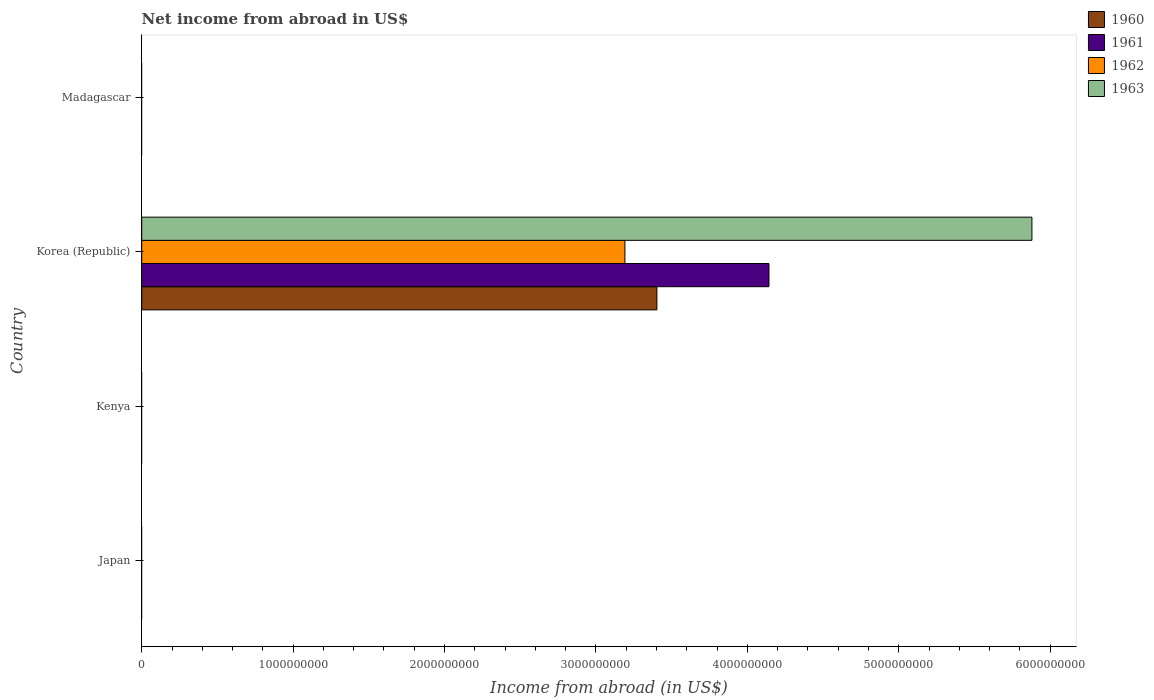How many different coloured bars are there?
Your answer should be very brief. 4. Are the number of bars per tick equal to the number of legend labels?
Provide a succinct answer. No. Are the number of bars on each tick of the Y-axis equal?
Your response must be concise. No. What is the label of the 3rd group of bars from the top?
Keep it short and to the point. Kenya. Across all countries, what is the maximum net income from abroad in 1963?
Offer a terse response. 5.88e+09. Across all countries, what is the minimum net income from abroad in 1961?
Keep it short and to the point. 0. What is the total net income from abroad in 1963 in the graph?
Your answer should be compact. 5.88e+09. What is the difference between the net income from abroad in 1961 in Kenya and the net income from abroad in 1962 in Madagascar?
Offer a terse response. 0. What is the average net income from abroad in 1963 per country?
Provide a short and direct response. 1.47e+09. What is the difference between the net income from abroad in 1960 and net income from abroad in 1963 in Korea (Republic)?
Your answer should be very brief. -2.48e+09. In how many countries, is the net income from abroad in 1963 greater than 200000000 US$?
Offer a terse response. 1. What is the difference between the highest and the lowest net income from abroad in 1962?
Keep it short and to the point. 3.19e+09. In how many countries, is the net income from abroad in 1962 greater than the average net income from abroad in 1962 taken over all countries?
Offer a very short reply. 1. Is it the case that in every country, the sum of the net income from abroad in 1963 and net income from abroad in 1960 is greater than the sum of net income from abroad in 1961 and net income from abroad in 1962?
Offer a very short reply. No. Is it the case that in every country, the sum of the net income from abroad in 1960 and net income from abroad in 1963 is greater than the net income from abroad in 1961?
Provide a succinct answer. No. Are all the bars in the graph horizontal?
Your response must be concise. Yes. Does the graph contain grids?
Offer a terse response. No. Where does the legend appear in the graph?
Ensure brevity in your answer.  Top right. How are the legend labels stacked?
Ensure brevity in your answer.  Vertical. What is the title of the graph?
Ensure brevity in your answer.  Net income from abroad in US$. Does "1961" appear as one of the legend labels in the graph?
Provide a succinct answer. Yes. What is the label or title of the X-axis?
Your answer should be very brief. Income from abroad (in US$). What is the Income from abroad (in US$) in 1960 in Japan?
Your answer should be very brief. 0. What is the Income from abroad (in US$) in 1961 in Japan?
Give a very brief answer. 0. What is the Income from abroad (in US$) of 1960 in Kenya?
Your response must be concise. 0. What is the Income from abroad (in US$) in 1961 in Kenya?
Your answer should be very brief. 0. What is the Income from abroad (in US$) of 1962 in Kenya?
Offer a terse response. 0. What is the Income from abroad (in US$) in 1960 in Korea (Republic)?
Offer a terse response. 3.40e+09. What is the Income from abroad (in US$) in 1961 in Korea (Republic)?
Make the answer very short. 4.14e+09. What is the Income from abroad (in US$) of 1962 in Korea (Republic)?
Your answer should be very brief. 3.19e+09. What is the Income from abroad (in US$) of 1963 in Korea (Republic)?
Give a very brief answer. 5.88e+09. What is the Income from abroad (in US$) in 1961 in Madagascar?
Give a very brief answer. 0. What is the Income from abroad (in US$) of 1963 in Madagascar?
Give a very brief answer. 0. Across all countries, what is the maximum Income from abroad (in US$) of 1960?
Provide a succinct answer. 3.40e+09. Across all countries, what is the maximum Income from abroad (in US$) in 1961?
Make the answer very short. 4.14e+09. Across all countries, what is the maximum Income from abroad (in US$) in 1962?
Offer a terse response. 3.19e+09. Across all countries, what is the maximum Income from abroad (in US$) of 1963?
Keep it short and to the point. 5.88e+09. Across all countries, what is the minimum Income from abroad (in US$) of 1960?
Ensure brevity in your answer.  0. Across all countries, what is the minimum Income from abroad (in US$) of 1962?
Keep it short and to the point. 0. What is the total Income from abroad (in US$) in 1960 in the graph?
Provide a short and direct response. 3.40e+09. What is the total Income from abroad (in US$) in 1961 in the graph?
Keep it short and to the point. 4.14e+09. What is the total Income from abroad (in US$) in 1962 in the graph?
Provide a succinct answer. 3.19e+09. What is the total Income from abroad (in US$) in 1963 in the graph?
Offer a very short reply. 5.88e+09. What is the average Income from abroad (in US$) of 1960 per country?
Give a very brief answer. 8.51e+08. What is the average Income from abroad (in US$) in 1961 per country?
Ensure brevity in your answer.  1.04e+09. What is the average Income from abroad (in US$) in 1962 per country?
Make the answer very short. 7.98e+08. What is the average Income from abroad (in US$) in 1963 per country?
Your response must be concise. 1.47e+09. What is the difference between the Income from abroad (in US$) of 1960 and Income from abroad (in US$) of 1961 in Korea (Republic)?
Provide a succinct answer. -7.40e+08. What is the difference between the Income from abroad (in US$) in 1960 and Income from abroad (in US$) in 1962 in Korea (Republic)?
Your answer should be compact. 2.11e+08. What is the difference between the Income from abroad (in US$) in 1960 and Income from abroad (in US$) in 1963 in Korea (Republic)?
Ensure brevity in your answer.  -2.48e+09. What is the difference between the Income from abroad (in US$) in 1961 and Income from abroad (in US$) in 1962 in Korea (Republic)?
Offer a terse response. 9.52e+08. What is the difference between the Income from abroad (in US$) of 1961 and Income from abroad (in US$) of 1963 in Korea (Republic)?
Ensure brevity in your answer.  -1.74e+09. What is the difference between the Income from abroad (in US$) of 1962 and Income from abroad (in US$) of 1963 in Korea (Republic)?
Ensure brevity in your answer.  -2.69e+09. What is the difference between the highest and the lowest Income from abroad (in US$) in 1960?
Offer a very short reply. 3.40e+09. What is the difference between the highest and the lowest Income from abroad (in US$) of 1961?
Give a very brief answer. 4.14e+09. What is the difference between the highest and the lowest Income from abroad (in US$) of 1962?
Your answer should be very brief. 3.19e+09. What is the difference between the highest and the lowest Income from abroad (in US$) of 1963?
Your answer should be compact. 5.88e+09. 